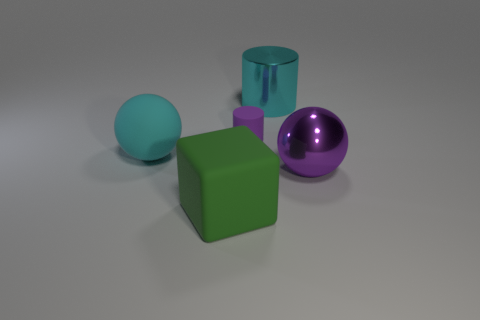Add 5 green matte blocks. How many objects exist? 10 Subtract all purple balls. How many balls are left? 1 Subtract all spheres. How many objects are left? 3 Subtract all gray cubes. Subtract all yellow spheres. How many cubes are left? 1 Subtract all small blue matte cylinders. Subtract all green things. How many objects are left? 4 Add 1 large objects. How many large objects are left? 5 Add 5 metallic objects. How many metallic objects exist? 7 Subtract 0 yellow blocks. How many objects are left? 5 Subtract 1 cylinders. How many cylinders are left? 1 